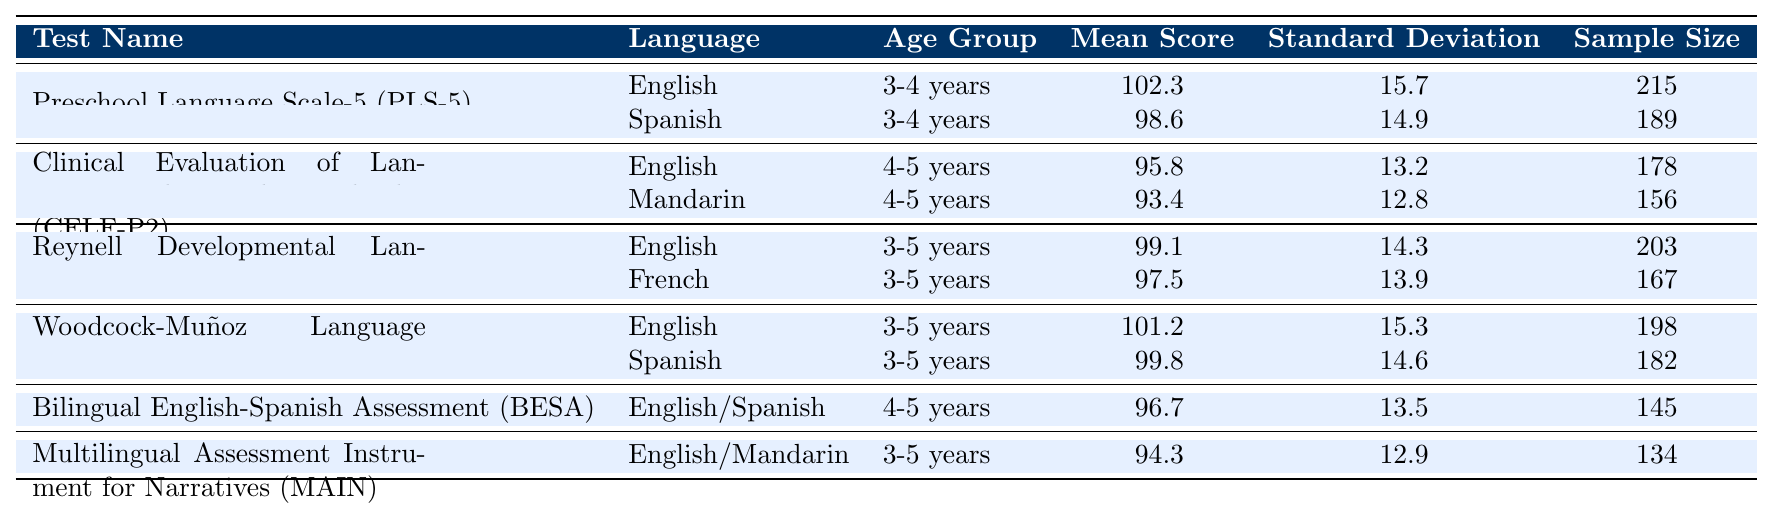What is the mean score for the Preschool Language Scale-5 (PLS-5) in English? According to the table, the mean score for the PLS-5 in English is specifically listed under the relevant heading, which shows a value of 102.3.
Answer: 102.3 What is the standard deviation of the mean score for the Clinical Evaluation of Language Fundamentals Preschool-2 (CELF-P2) in Mandarin? The standard deviation for the CELF-P2 in Mandarin can be found in the corresponding row of the table, which displays a value of 12.8.
Answer: 12.8 How many participants were involved in the Reynell Developmental Language Scales III (RDLS-III) for French? The sample size for the RDLS-III in French is provided in the table under the French entry, which indicates a total of 167 participants.
Answer: 167 Is the mean score for the Woodcock-Muñoz Language Survey-Revised (WMLS-R) in Spanish higher than 100? The mean score for the WMLS-R in Spanish is 99.8, which is lower than 100, thus the statement is false.
Answer: No What is the difference in mean scores between the English and Spanish versions of the Preschool Language Scale-5 (PLS-5)? The mean score for English is 102.3, and for Spanish, it is 98.6. The difference is calculated as 102.3 - 98.6 = 3.7.
Answer: 3.7 What is the average mean score for the Clinical Evaluation of Language Fundamentals Preschool-2 (CELF-P2) across both languages? The mean scores for CELF-P2 are 95.8 for English and 93.4 for Mandarin. The average is computed as (95.8 + 93.4) / 2 = 94.6.
Answer: 94.6 Which test has the lowest mean score among all tests listed for the age group 3-5 years? Looking at the mean scores for all tests in the age group 3-5 years, the lowest value appears to be for the Multilingual Assessment Instrument for Narratives (MAIN), which is 94.3.
Answer: 94.3 What is the total sample size of all tests conducted in English? The total sample size of tests in English is calculated by summing the sample sizes for all English tests: 215 (PLS-5) + 178 (CELF-P2) + 203 (RDLS-III) + 198 (WMLS-R) = 794.
Answer: 794 Which language yields the highest mean score in the table? By reviewing mean scores across all entries, English in the Preschool Language Scale-5 (PLS-5) at 102.3 presents the highest mean score, making it the highest.
Answer: English (PLS-5: 102.3) What percentage of the total sample size for the Reynolds Developmental Language Scales III (RDLS-III) comes from the English version? The total sample size for RDLS-III is 203 (English) + 167 (French) = 370. The percentage contributed by English is (203/370) * 100 ≈ 54.86%.
Answer: 54.86% 